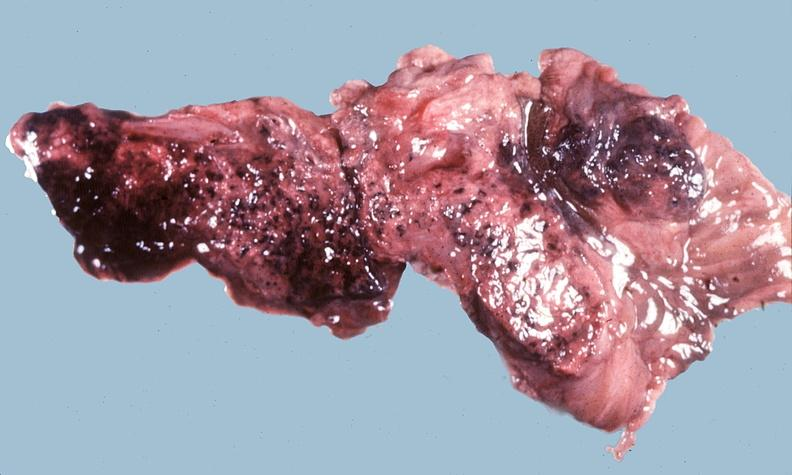does testicle show acute hemorrhagic pancreatitis?
Answer the question using a single word or phrase. No 